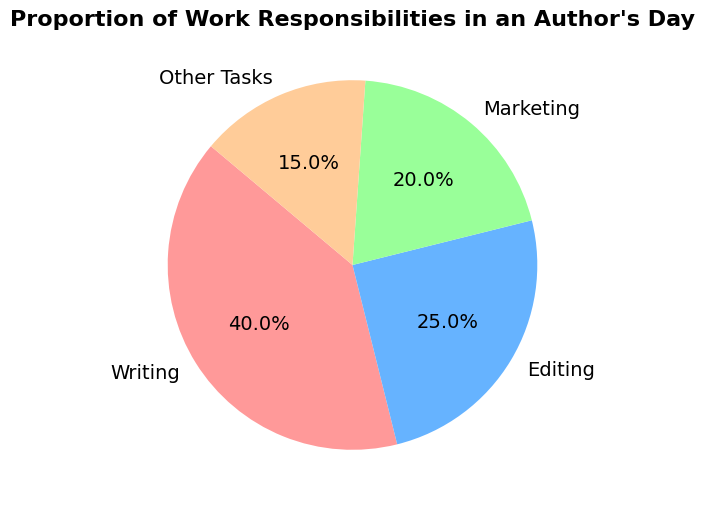What proportion of an author's day is spent on Marketing compared to Other Tasks? First, look for the proportions of both Marketing and Other Tasks in the pie chart. Marketing has 20%, and Other Tasks have 15%. Therefore, Marketing occupies a larger proportion.
Answer: Marketing is larger What is the combined percentage of time spent on Editing and Marketing? Identify the individual proportions for Editing (25%) and Marketing (20%). Add them together: 25% + 20% = 45%.
Answer: 45% Which category has the least amount of time allocated? Look at the chart and identify the category with the smallest slice. The Other Tasks category has the smallest slice at 15%.
Answer: Other Tasks By how much does the time spent on Writing exceed the time spent on Editing? Identify the proportions for Writing (40%) and Editing (25%). Subtract the proportion of Editing from Writing: 40% - 25% = 15%.
Answer: 15% What is the total proportion of time not spent on Writing? Identify the proportion of time spent on Writing (40%). Subtract that from the total amount, which is 100%: 100% - 40% = 60%.
Answer: 60% If an author works an 8-hour day, how much time is spent on Other Tasks? Identify the proportion for Other Tasks (15%), then find 15% of 8 hours. Multiply 8 by 0.15: 8 * 0.15 = 1.2 hours.
Answer: 1.2 hours Which two categories together take up exactly 60% of the author’s time? Identify the proportions for all categories: Writing (40%), Editing (25%), Marketing (20%), and Other Tasks (15%). The categories of Editing (25%) and Marketing (20%) sum to 45%, and Writing (40%) and Other Tasks (15%) sum to 55%; none pair up to exactly 60%. However, Editing and Other Tasks together (25% + 15%) sum to 40%, missing the mark. Assess Writing (40%) and Marketing (20%): 40% + 20% = 60%.
Answer: Writing and Marketing 